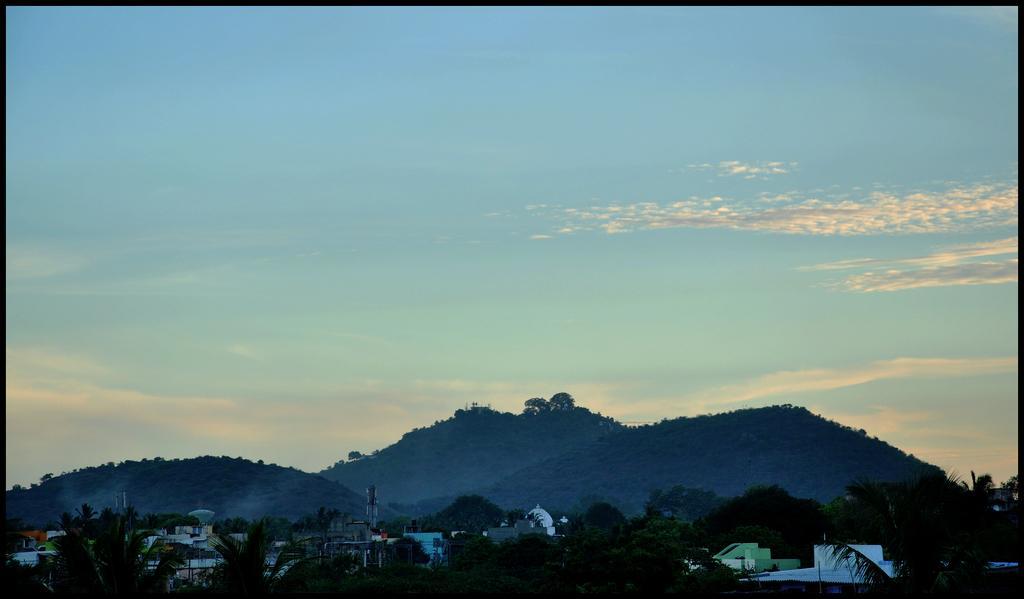Can you describe this image briefly? At the bottom of the picture we can see trees, buildings, cell phone towers and hills. The hills are covered with trees. In the background it is sky. 